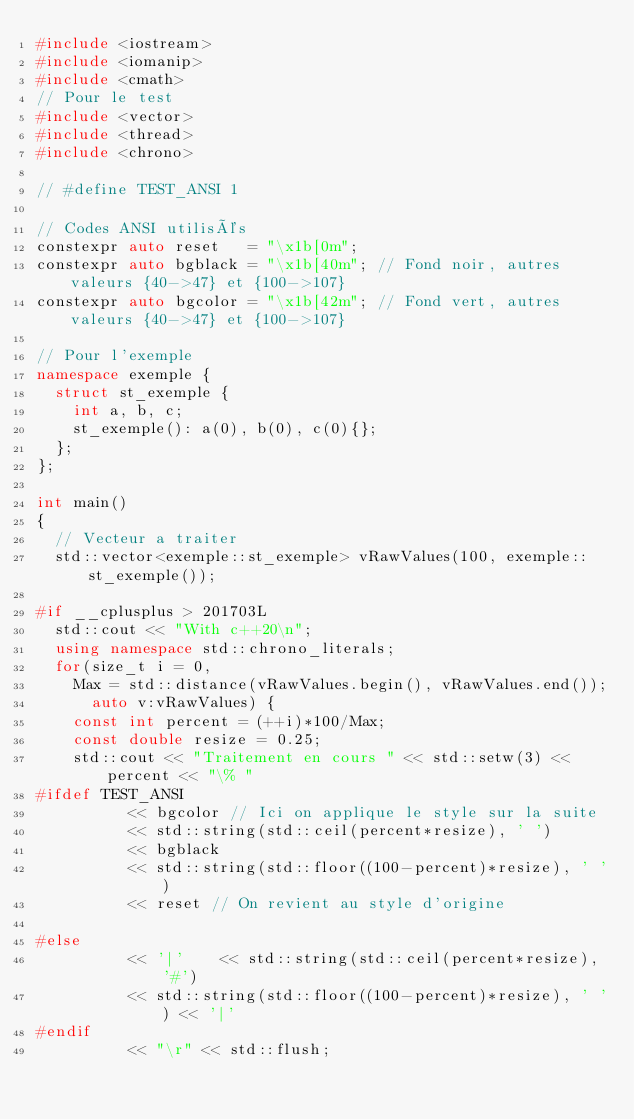Convert code to text. <code><loc_0><loc_0><loc_500><loc_500><_C++_>#include <iostream>
#include <iomanip>
#include <cmath>
// Pour le test
#include <vector>
#include <thread>
#include <chrono>

// #define TEST_ANSI 1

// Codes ANSI utilisés
constexpr auto reset   = "\x1b[0m";
constexpr auto bgblack = "\x1b[40m"; // Fond noir, autres valeurs {40->47} et {100->107}
constexpr auto bgcolor = "\x1b[42m"; // Fond vert, autres valeurs {40->47} et {100->107}

// Pour l'exemple
namespace exemple {
  struct st_exemple {
    int a, b, c;
    st_exemple(): a(0), b(0), c(0){};
  };
};

int main()
{
  // Vecteur a traiter
  std::vector<exemple::st_exemple> vRawValues(100, exemple::st_exemple());

#if __cplusplus > 201703L
  std::cout << "With c++20\n";
  using namespace std::chrono_literals;
  for(size_t i = 0,
	Max = std::distance(vRawValues.begin(), vRawValues.end());
      auto v:vRawValues) {
    const int percent = (++i)*100/Max;
    const double resize = 0.25;
    std::cout << "Traitement en cours " << std::setw(3) << percent << "\% "
#ifdef TEST_ANSI
	      << bgcolor // Ici on applique le style sur la suite
	      << std::string(std::ceil(percent*resize), ' ')
	      << bgblack
	      << std::string(std::floor((100-percent)*resize), ' ')
	      << reset // On revient au style d'origine

#else
	      << '|'	<< std::string(std::ceil(percent*resize), '#')
	      << std::string(std::floor((100-percent)*resize), ' ') << '|'
#endif
	      << "\r" << std::flush;</code> 